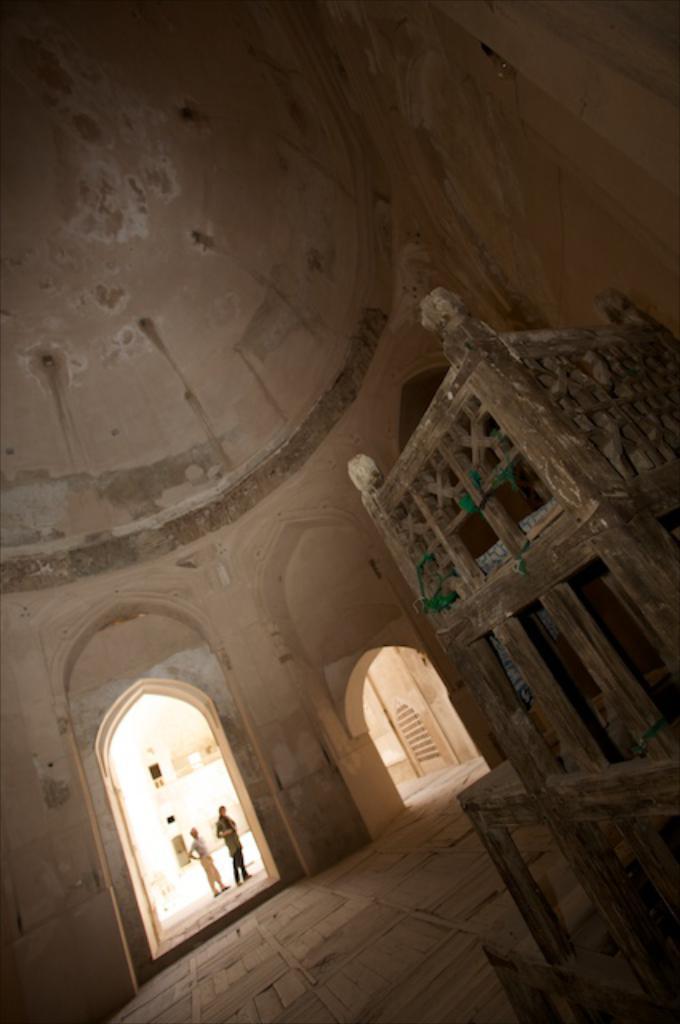Could you give a brief overview of what you see in this image? This image is clicked inside the tomb. There are two persons near the entrance. On the right side there is a wooden object. 